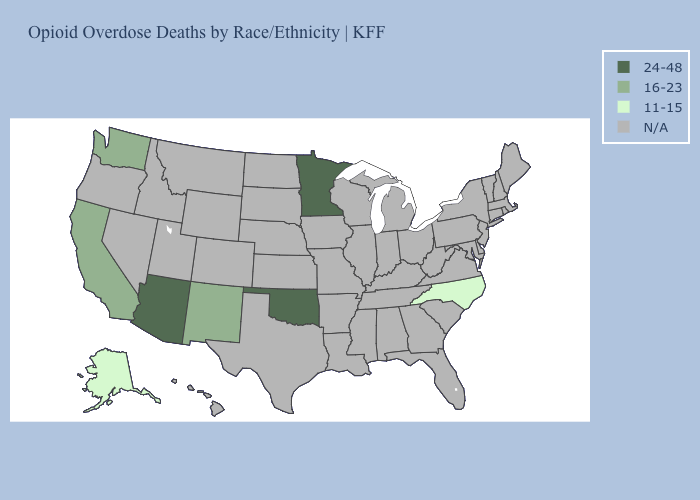Name the states that have a value in the range N/A?
Concise answer only. Alabama, Arkansas, Colorado, Connecticut, Delaware, Florida, Georgia, Hawaii, Idaho, Illinois, Indiana, Iowa, Kansas, Kentucky, Louisiana, Maine, Maryland, Massachusetts, Michigan, Mississippi, Missouri, Montana, Nebraska, Nevada, New Hampshire, New Jersey, New York, North Dakota, Ohio, Oregon, Pennsylvania, Rhode Island, South Carolina, South Dakota, Tennessee, Texas, Utah, Vermont, Virginia, West Virginia, Wisconsin, Wyoming. Which states hav the highest value in the West?
Short answer required. Arizona. Does New Mexico have the highest value in the USA?
Be succinct. No. What is the value of South Dakota?
Quick response, please. N/A. Does the map have missing data?
Give a very brief answer. Yes. What is the value of South Dakota?
Quick response, please. N/A. Name the states that have a value in the range 11-15?
Write a very short answer. Alaska, North Carolina. Name the states that have a value in the range 16-23?
Keep it brief. California, New Mexico, Washington. Does Alaska have the lowest value in the USA?
Be succinct. Yes. Name the states that have a value in the range N/A?
Be succinct. Alabama, Arkansas, Colorado, Connecticut, Delaware, Florida, Georgia, Hawaii, Idaho, Illinois, Indiana, Iowa, Kansas, Kentucky, Louisiana, Maine, Maryland, Massachusetts, Michigan, Mississippi, Missouri, Montana, Nebraska, Nevada, New Hampshire, New Jersey, New York, North Dakota, Ohio, Oregon, Pennsylvania, Rhode Island, South Carolina, South Dakota, Tennessee, Texas, Utah, Vermont, Virginia, West Virginia, Wisconsin, Wyoming. What is the lowest value in the USA?
Answer briefly. 11-15. Name the states that have a value in the range N/A?
Answer briefly. Alabama, Arkansas, Colorado, Connecticut, Delaware, Florida, Georgia, Hawaii, Idaho, Illinois, Indiana, Iowa, Kansas, Kentucky, Louisiana, Maine, Maryland, Massachusetts, Michigan, Mississippi, Missouri, Montana, Nebraska, Nevada, New Hampshire, New Jersey, New York, North Dakota, Ohio, Oregon, Pennsylvania, Rhode Island, South Carolina, South Dakota, Tennessee, Texas, Utah, Vermont, Virginia, West Virginia, Wisconsin, Wyoming. Name the states that have a value in the range 24-48?
Write a very short answer. Arizona, Minnesota, Oklahoma. 